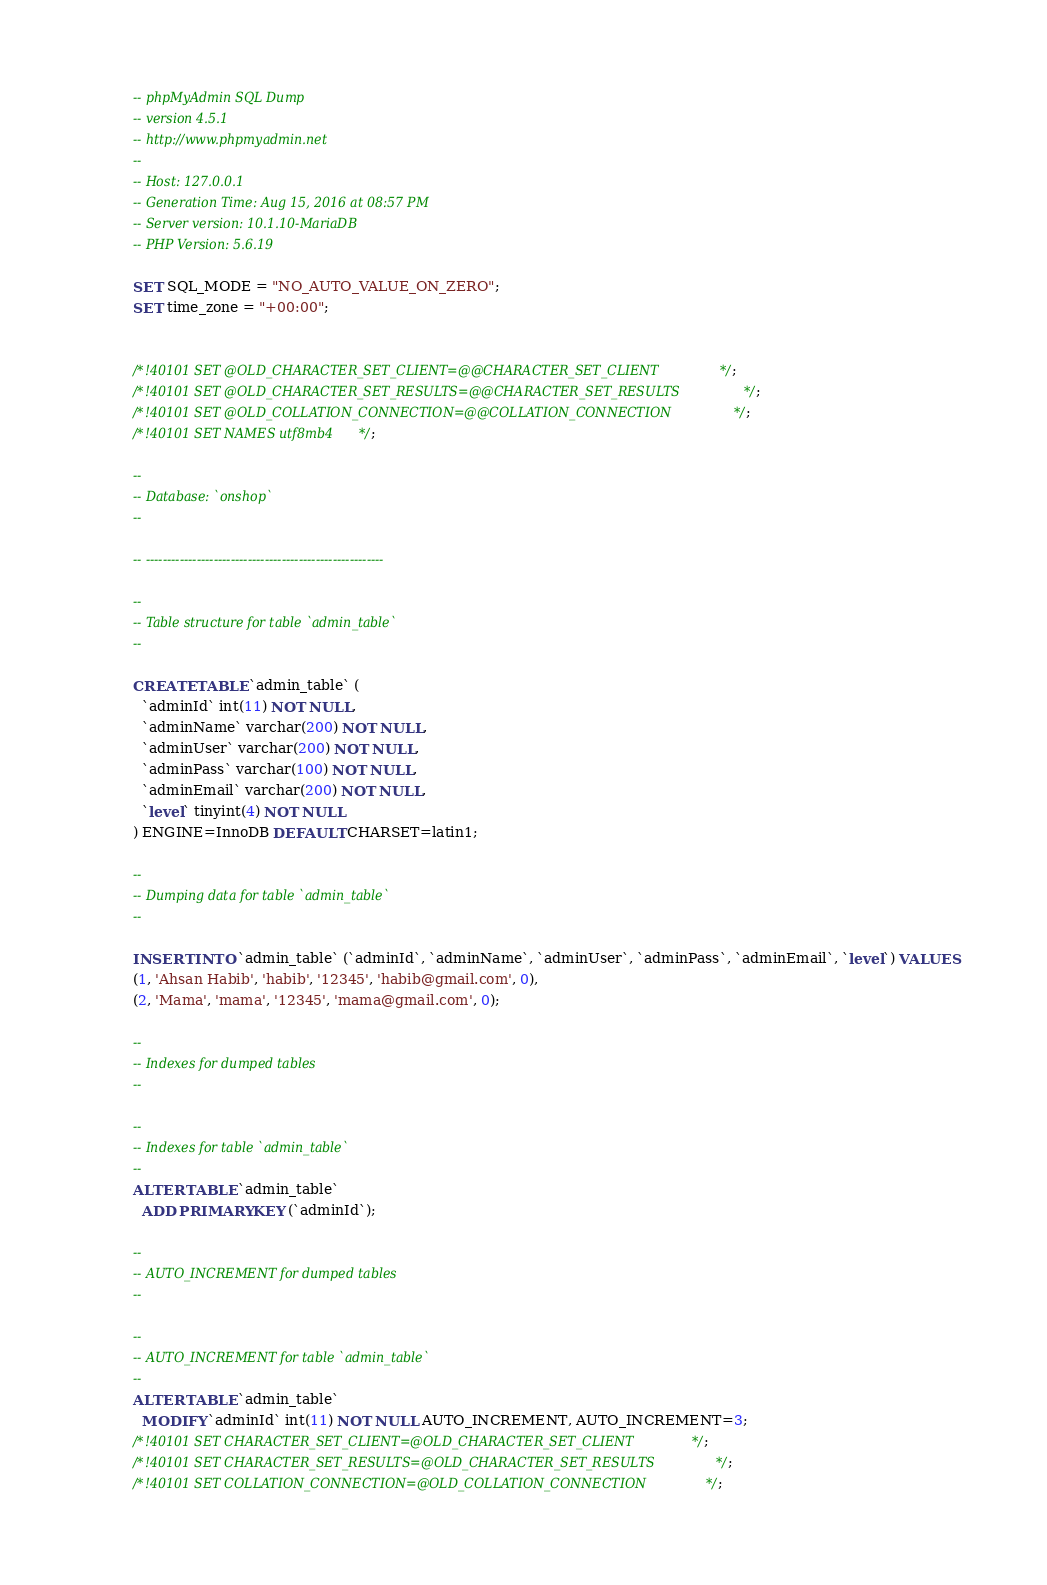Convert code to text. <code><loc_0><loc_0><loc_500><loc_500><_SQL_>-- phpMyAdmin SQL Dump
-- version 4.5.1
-- http://www.phpmyadmin.net
--
-- Host: 127.0.0.1
-- Generation Time: Aug 15, 2016 at 08:57 PM
-- Server version: 10.1.10-MariaDB
-- PHP Version: 5.6.19

SET SQL_MODE = "NO_AUTO_VALUE_ON_ZERO";
SET time_zone = "+00:00";


/*!40101 SET @OLD_CHARACTER_SET_CLIENT=@@CHARACTER_SET_CLIENT */;
/*!40101 SET @OLD_CHARACTER_SET_RESULTS=@@CHARACTER_SET_RESULTS */;
/*!40101 SET @OLD_COLLATION_CONNECTION=@@COLLATION_CONNECTION */;
/*!40101 SET NAMES utf8mb4 */;

--
-- Database: `onshop`
--

-- --------------------------------------------------------

--
-- Table structure for table `admin_table`
--

CREATE TABLE `admin_table` (
  `adminId` int(11) NOT NULL,
  `adminName` varchar(200) NOT NULL,
  `adminUser` varchar(200) NOT NULL,
  `adminPass` varchar(100) NOT NULL,
  `adminEmail` varchar(200) NOT NULL,
  `level` tinyint(4) NOT NULL
) ENGINE=InnoDB DEFAULT CHARSET=latin1;

--
-- Dumping data for table `admin_table`
--

INSERT INTO `admin_table` (`adminId`, `adminName`, `adminUser`, `adminPass`, `adminEmail`, `level`) VALUES
(1, 'Ahsan Habib', 'habib', '12345', 'habib@gmail.com', 0),
(2, 'Mama', 'mama', '12345', 'mama@gmail.com', 0);

--
-- Indexes for dumped tables
--

--
-- Indexes for table `admin_table`
--
ALTER TABLE `admin_table`
  ADD PRIMARY KEY (`adminId`);

--
-- AUTO_INCREMENT for dumped tables
--

--
-- AUTO_INCREMENT for table `admin_table`
--
ALTER TABLE `admin_table`
  MODIFY `adminId` int(11) NOT NULL AUTO_INCREMENT, AUTO_INCREMENT=3;
/*!40101 SET CHARACTER_SET_CLIENT=@OLD_CHARACTER_SET_CLIENT */;
/*!40101 SET CHARACTER_SET_RESULTS=@OLD_CHARACTER_SET_RESULTS */;
/*!40101 SET COLLATION_CONNECTION=@OLD_COLLATION_CONNECTION */;
</code> 